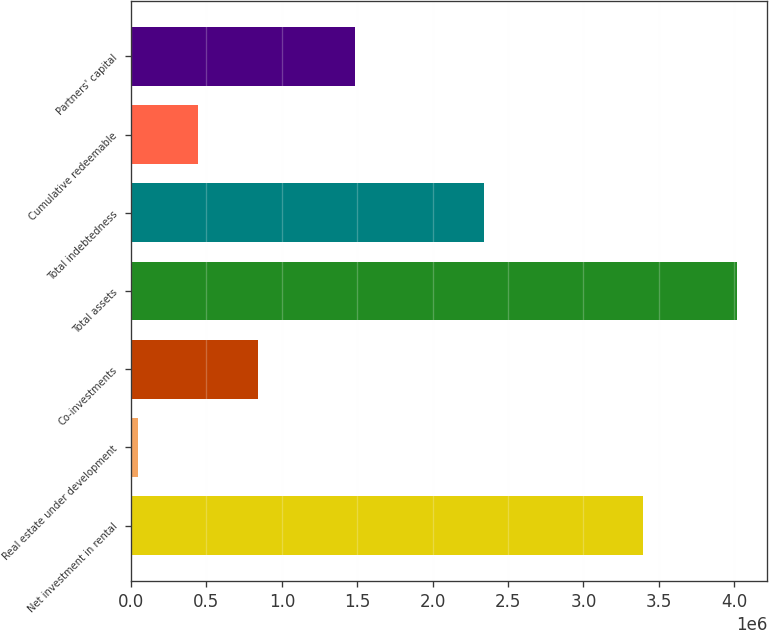Convert chart. <chart><loc_0><loc_0><loc_500><loc_500><bar_chart><fcel>Net investment in rental<fcel>Real estate under development<fcel>Co-investments<fcel>Total assets<fcel>Total indebtedness<fcel>Cumulative redeemable<fcel>Partners' capital<nl><fcel>3.39304e+06<fcel>44280<fcel>839328<fcel>4.01952e+06<fcel>2.34341e+06<fcel>441804<fcel>1.48691e+06<nl></chart> 